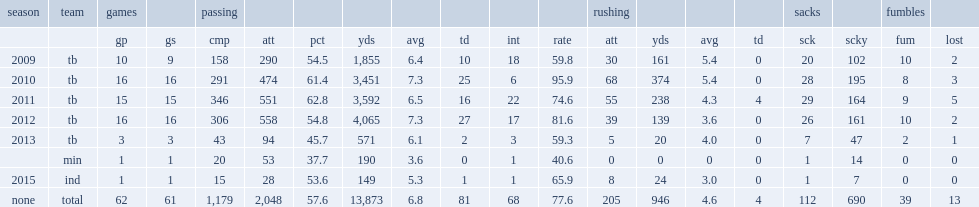Write the full table. {'header': ['season', 'team', 'games', '', 'passing', '', '', '', '', '', '', '', 'rushing', '', '', '', 'sacks', '', 'fumbles', ''], 'rows': [['', '', 'gp', 'gs', 'cmp', 'att', 'pct', 'yds', 'avg', 'td', 'int', 'rate', 'att', 'yds', 'avg', 'td', 'sck', 'scky', 'fum', 'lost'], ['2009', 'tb', '10', '9', '158', '290', '54.5', '1,855', '6.4', '10', '18', '59.8', '30', '161', '5.4', '0', '20', '102', '10', '2'], ['2010', 'tb', '16', '16', '291', '474', '61.4', '3,451', '7.3', '25', '6', '95.9', '68', '374', '5.4', '0', '28', '195', '8', '3'], ['2011', 'tb', '15', '15', '346', '551', '62.8', '3,592', '6.5', '16', '22', '74.6', '55', '238', '4.3', '4', '29', '164', '9', '5'], ['2012', 'tb', '16', '16', '306', '558', '54.8', '4,065', '7.3', '27', '17', '81.6', '39', '139', '3.6', '0', '26', '161', '10', '2'], ['2013', 'tb', '3', '3', '43', '94', '45.7', '571', '6.1', '2', '3', '59.3', '5', '20', '4.0', '0', '7', '47', '2', '1'], ['', 'min', '1', '1', '20', '53', '37.7', '190', '3.6', '0', '1', '40.6', '0', '0', '0', '0', '1', '14', '0', '0'], ['2015', 'ind', '1', '1', '15', '28', '53.6', '149', '5.3', '1', '1', '65.9', '8', '24', '3.0', '0', '1', '7', '0', '0'], ['none', 'total', '62', '61', '1,179', '2,048', '57.6', '13,873', '6.8', '81', '68', '77.6', '205', '946', '4.6', '4', '112', '690', '39', '13']]} What was the passing rate that josh freeman got in 2013? 59.3. 